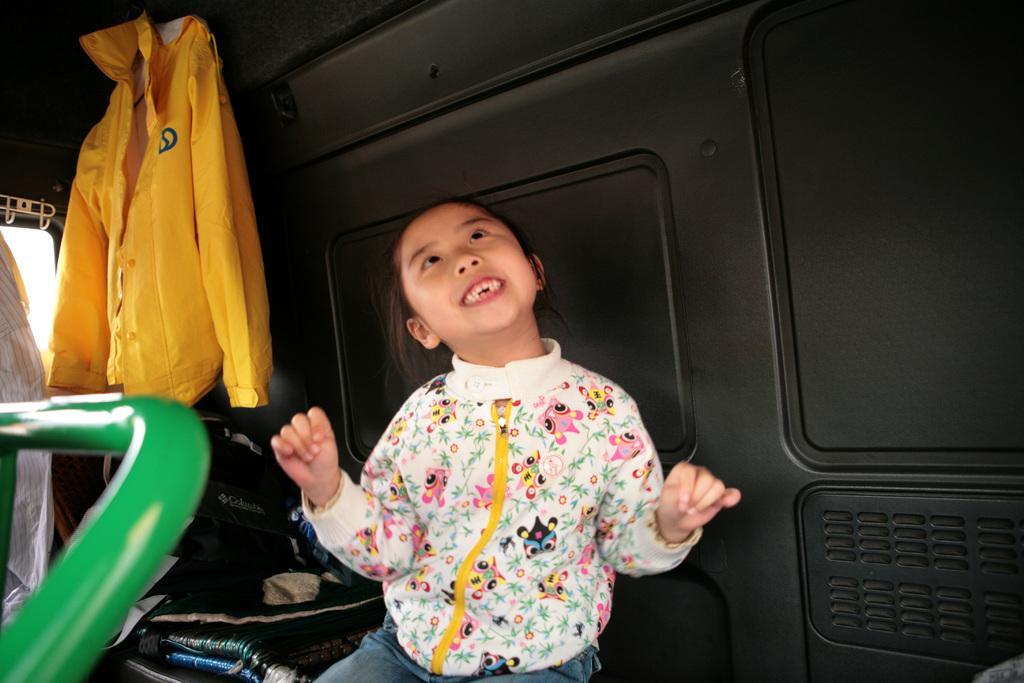Can you describe this image briefly? In the picture we can see a child standing, looking upwards and smiling, in the background, we can see a wall which is black in color with some designs on it and near to it, we can see a yellow color shirt which is hung to the ceiling, and to the bottom we can see some things are kept. 